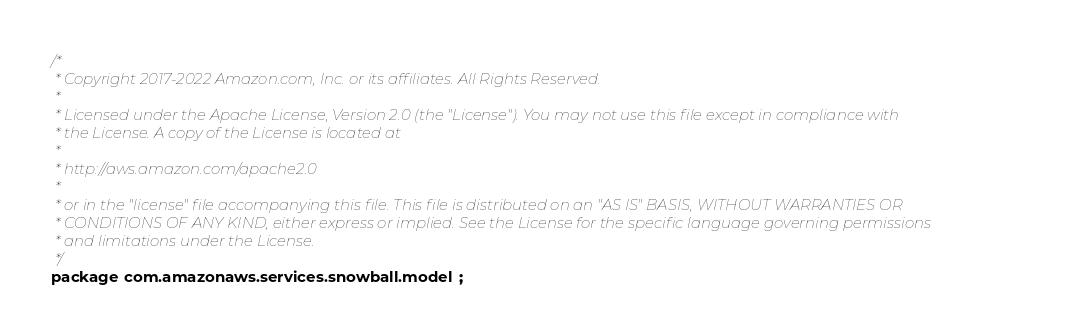Convert code to text. <code><loc_0><loc_0><loc_500><loc_500><_Java_>/*
 * Copyright 2017-2022 Amazon.com, Inc. or its affiliates. All Rights Reserved.
 * 
 * Licensed under the Apache License, Version 2.0 (the "License"). You may not use this file except in compliance with
 * the License. A copy of the License is located at
 * 
 * http://aws.amazon.com/apache2.0
 * 
 * or in the "license" file accompanying this file. This file is distributed on an "AS IS" BASIS, WITHOUT WARRANTIES OR
 * CONDITIONS OF ANY KIND, either express or implied. See the License for the specific language governing permissions
 * and limitations under the License.
 */
package com.amazonaws.services.snowball.model;
</code> 